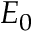<formula> <loc_0><loc_0><loc_500><loc_500>E _ { 0 }</formula> 